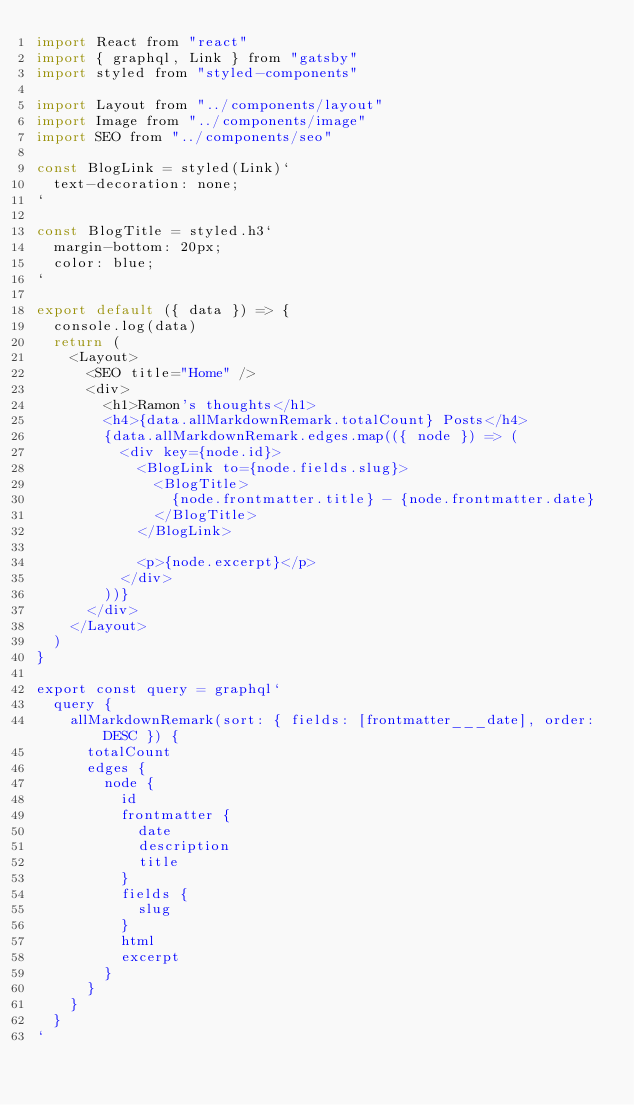Convert code to text. <code><loc_0><loc_0><loc_500><loc_500><_JavaScript_>import React from "react"
import { graphql, Link } from "gatsby"
import styled from "styled-components"

import Layout from "../components/layout"
import Image from "../components/image"
import SEO from "../components/seo"

const BlogLink = styled(Link)`
  text-decoration: none;
`

const BlogTitle = styled.h3`
  margin-bottom: 20px;
  color: blue;
`

export default ({ data }) => {
  console.log(data)
  return (
    <Layout>
      <SEO title="Home" />
      <div>
        <h1>Ramon's thoughts</h1>
        <h4>{data.allMarkdownRemark.totalCount} Posts</h4>
        {data.allMarkdownRemark.edges.map(({ node }) => (
          <div key={node.id}>
            <BlogLink to={node.fields.slug}>
              <BlogTitle>
                {node.frontmatter.title} - {node.frontmatter.date}
              </BlogTitle>
            </BlogLink>

            <p>{node.excerpt}</p>
          </div>
        ))}
      </div>
    </Layout>
  )
}

export const query = graphql`
  query {
    allMarkdownRemark(sort: { fields: [frontmatter___date], order: DESC }) {
      totalCount
      edges {
        node {
          id
          frontmatter {
            date
            description
            title
          }
          fields {
            slug
          }
          html
          excerpt
        }
      }
    }
  }
`
</code> 